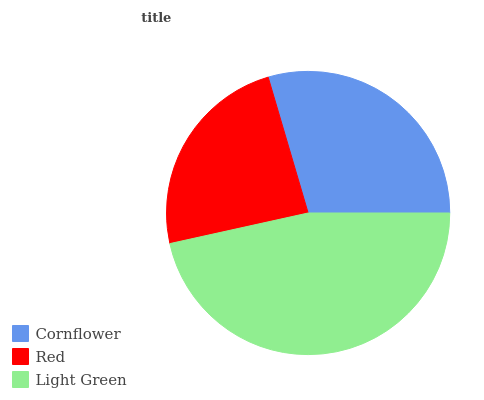Is Red the minimum?
Answer yes or no. Yes. Is Light Green the maximum?
Answer yes or no. Yes. Is Light Green the minimum?
Answer yes or no. No. Is Red the maximum?
Answer yes or no. No. Is Light Green greater than Red?
Answer yes or no. Yes. Is Red less than Light Green?
Answer yes or no. Yes. Is Red greater than Light Green?
Answer yes or no. No. Is Light Green less than Red?
Answer yes or no. No. Is Cornflower the high median?
Answer yes or no. Yes. Is Cornflower the low median?
Answer yes or no. Yes. Is Light Green the high median?
Answer yes or no. No. Is Red the low median?
Answer yes or no. No. 